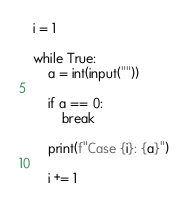Convert code to text. <code><loc_0><loc_0><loc_500><loc_500><_Python_>i = 1

while True:
    a = int(input(""))
    
    if a == 0:
        break
    
    print(f"Case {i}: {a}")
    
    i += 1
</code> 